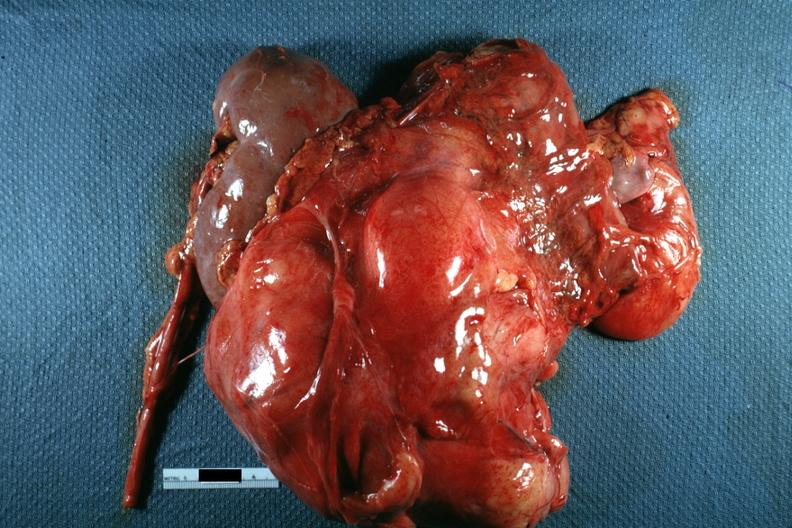what is present?
Answer the question using a single word or phrase. Abdomen 